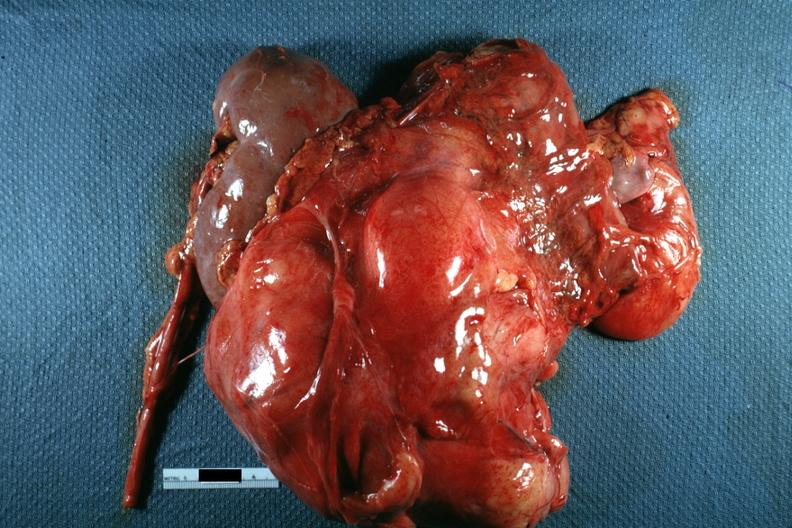what is present?
Answer the question using a single word or phrase. Abdomen 